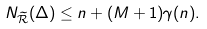<formula> <loc_0><loc_0><loc_500><loc_500>N _ { \widetilde { \mathcal { R } } } ( \Delta ) \leq n + ( M + 1 ) \gamma ( n ) .</formula> 